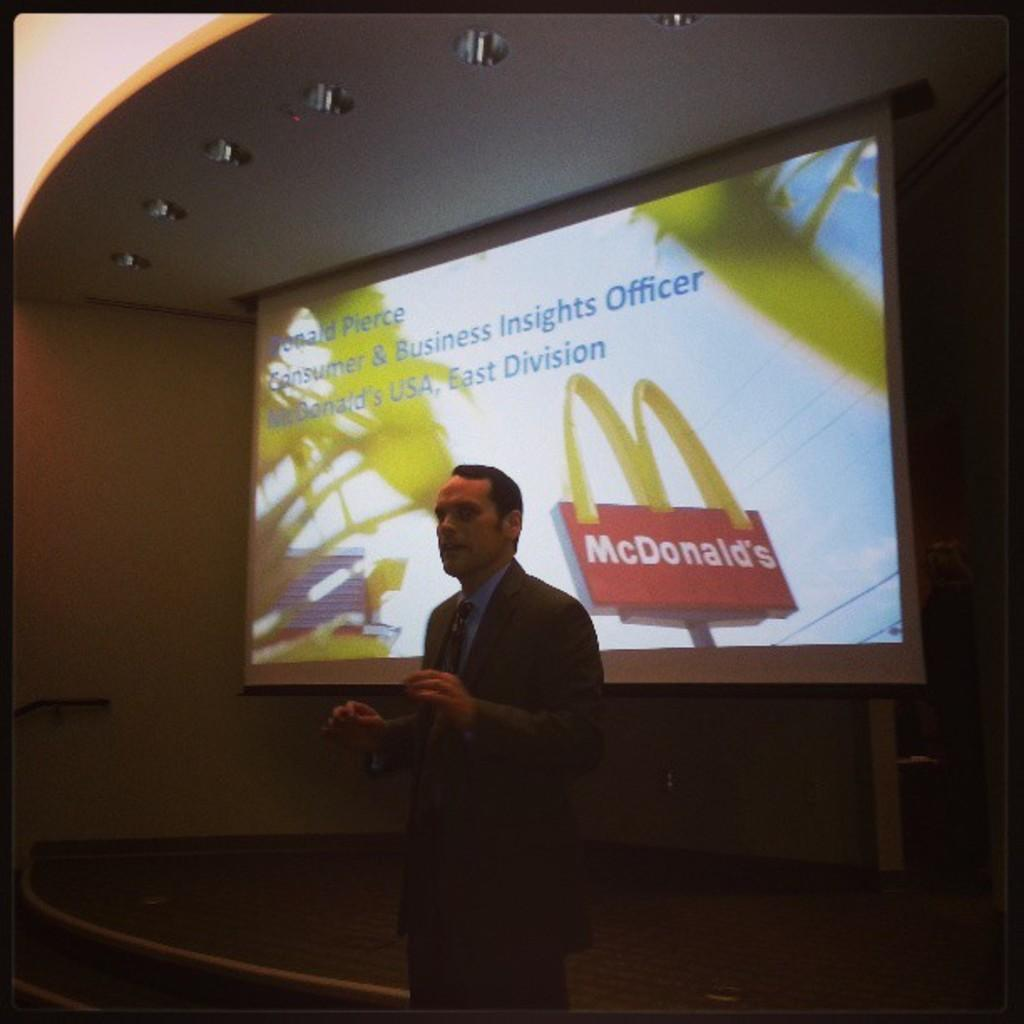What is the main subject of the image? There is a man standing in the center of the image. What is the man doing in the image? The man is talking in the image. What can be seen in the background of the image? There is a screen, a wall, and lights in the background of the image. What type of stitch is the man using to sew a button on his shirt in the image? There is no stitch or button-sewing activity present in the image; the man is simply talking. 